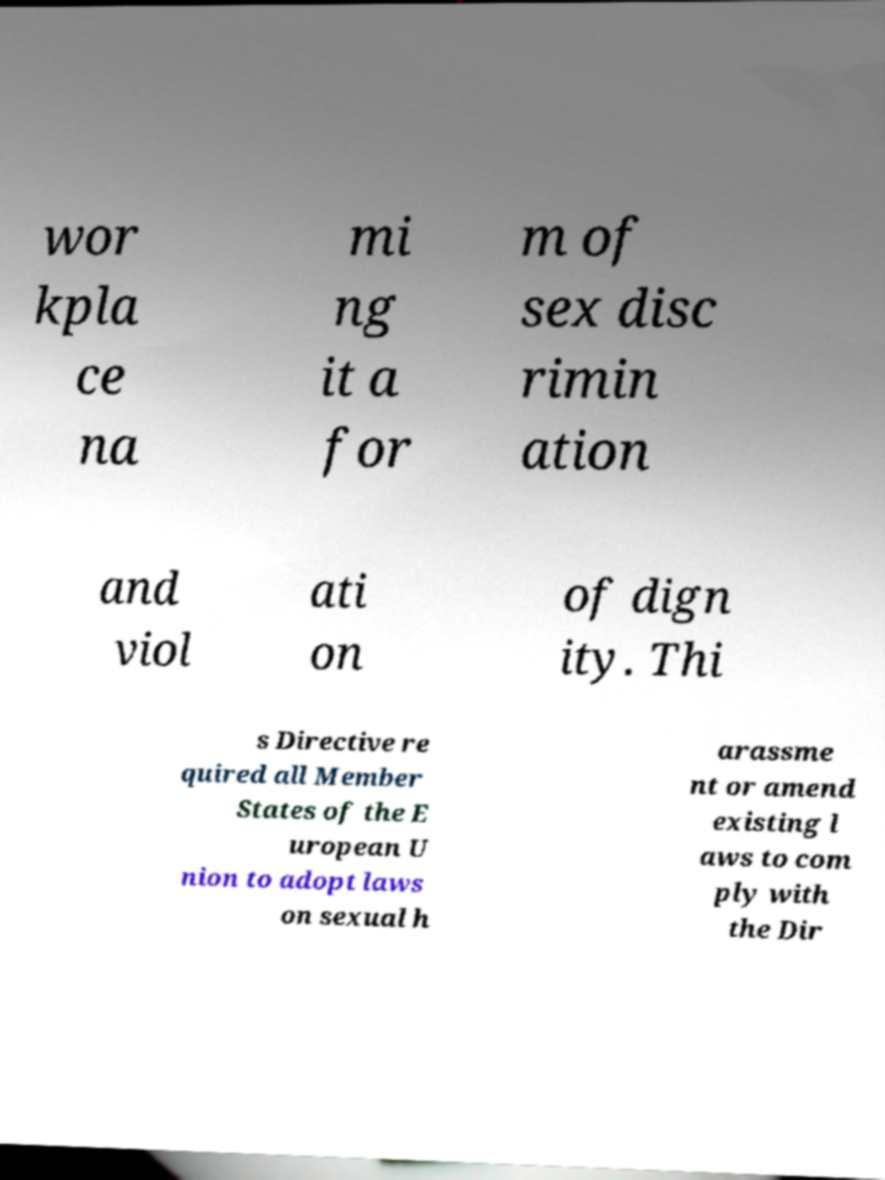For documentation purposes, I need the text within this image transcribed. Could you provide that? wor kpla ce na mi ng it a for m of sex disc rimin ation and viol ati on of dign ity. Thi s Directive re quired all Member States of the E uropean U nion to adopt laws on sexual h arassme nt or amend existing l aws to com ply with the Dir 